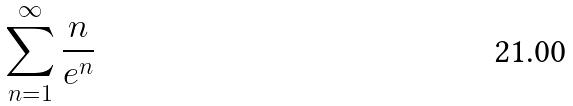<formula> <loc_0><loc_0><loc_500><loc_500>\sum _ { n = 1 } ^ { \infty } \frac { n } { e ^ { n } }</formula> 